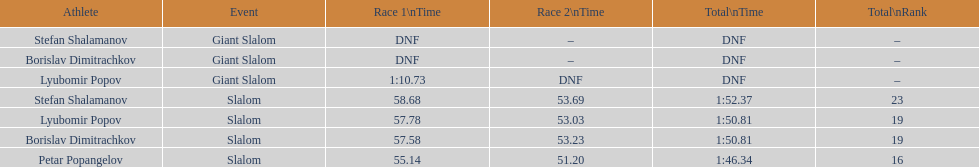Who came after borislav dimitrachkov and it's time for slalom Petar Popangelov. 